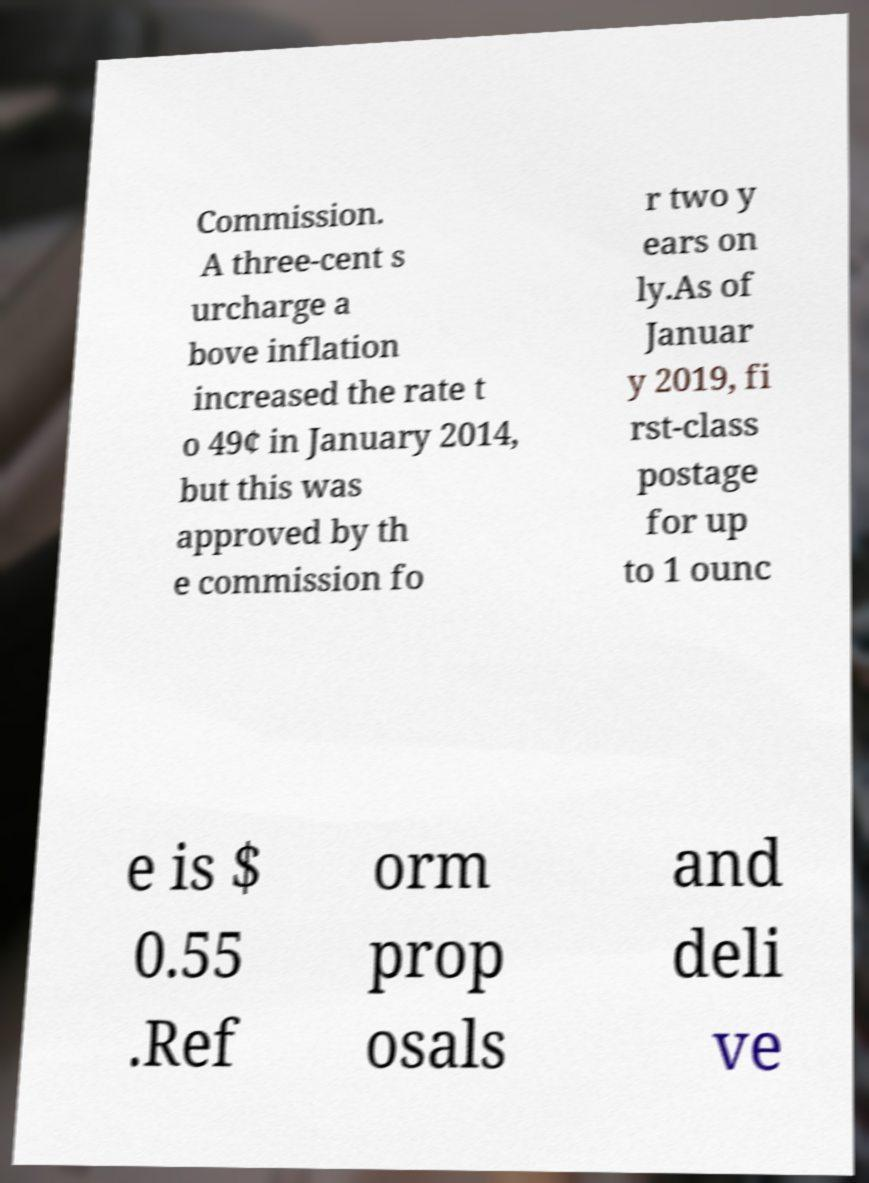There's text embedded in this image that I need extracted. Can you transcribe it verbatim? Commission. A three-cent s urcharge a bove inflation increased the rate t o 49¢ in January 2014, but this was approved by th e commission fo r two y ears on ly.As of Januar y 2019, fi rst-class postage for up to 1 ounc e is $ 0.55 .Ref orm prop osals and deli ve 